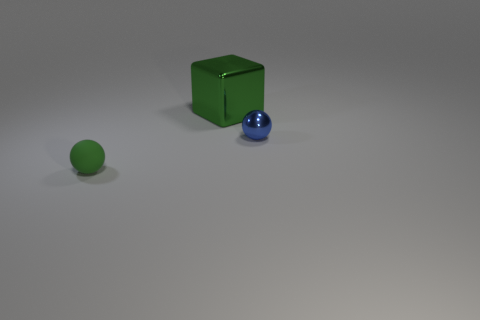Are there any other things that have the same color as the block? Yes, the sphere to the left shares a similar shade of green with the block, illustrating how objects in the scene can have matching colors even when their shapes and materials differ. 